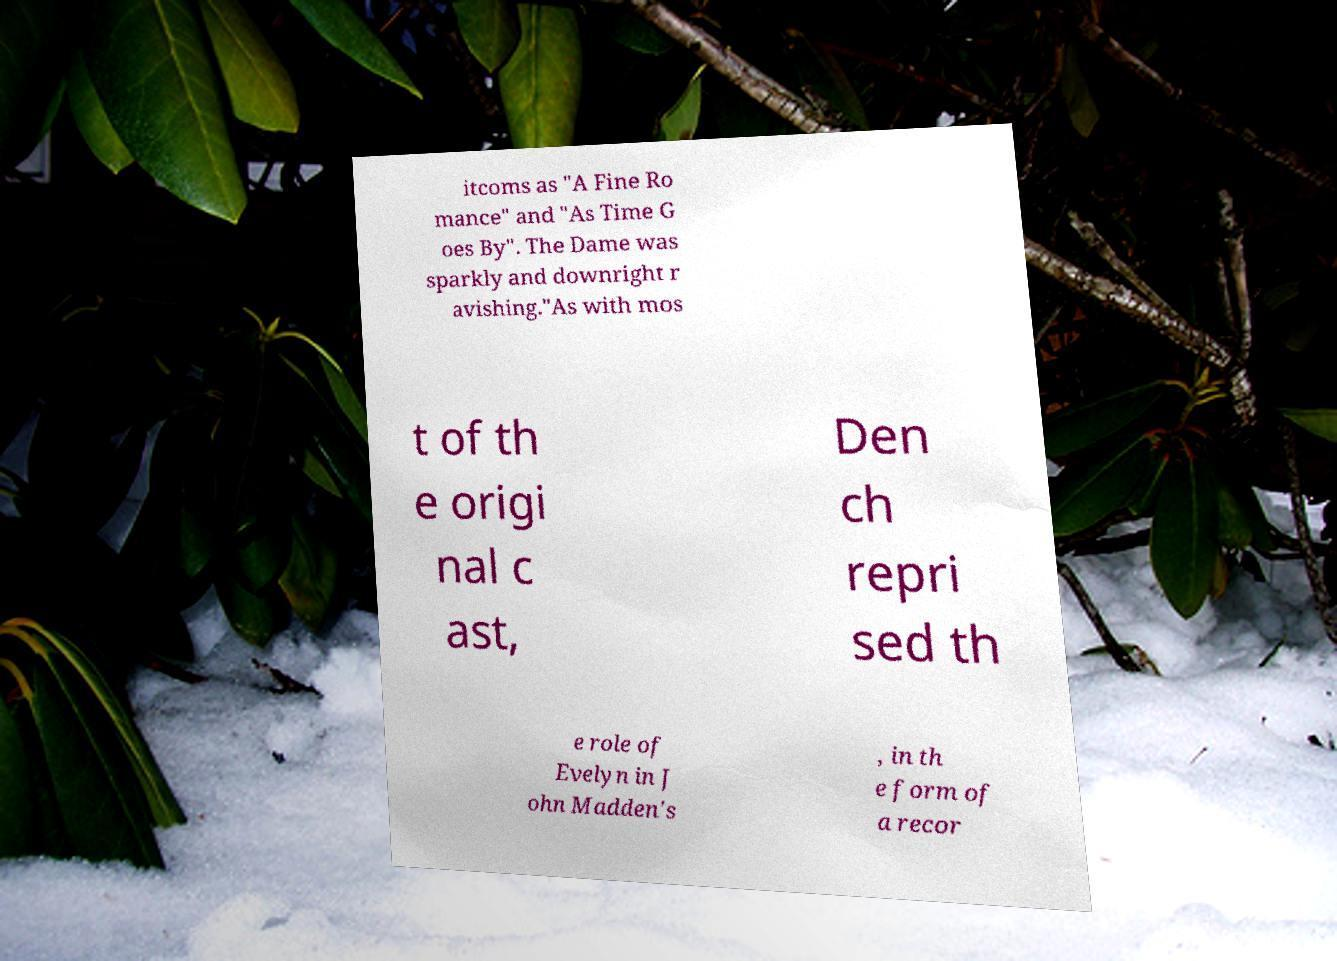Could you assist in decoding the text presented in this image and type it out clearly? itcoms as "A Fine Ro mance" and "As Time G oes By". The Dame was sparkly and downright r avishing."As with mos t of th e origi nal c ast, Den ch repri sed th e role of Evelyn in J ohn Madden's , in th e form of a recor 